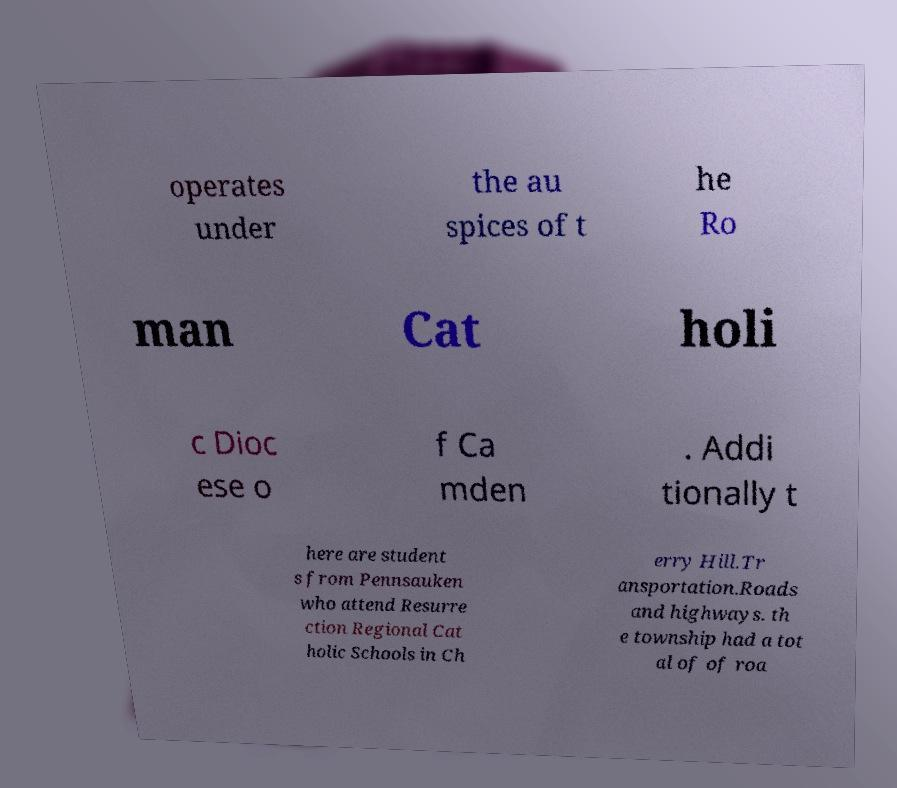Can you read and provide the text displayed in the image?This photo seems to have some interesting text. Can you extract and type it out for me? operates under the au spices of t he Ro man Cat holi c Dioc ese o f Ca mden . Addi tionally t here are student s from Pennsauken who attend Resurre ction Regional Cat holic Schools in Ch erry Hill.Tr ansportation.Roads and highways. th e township had a tot al of of roa 